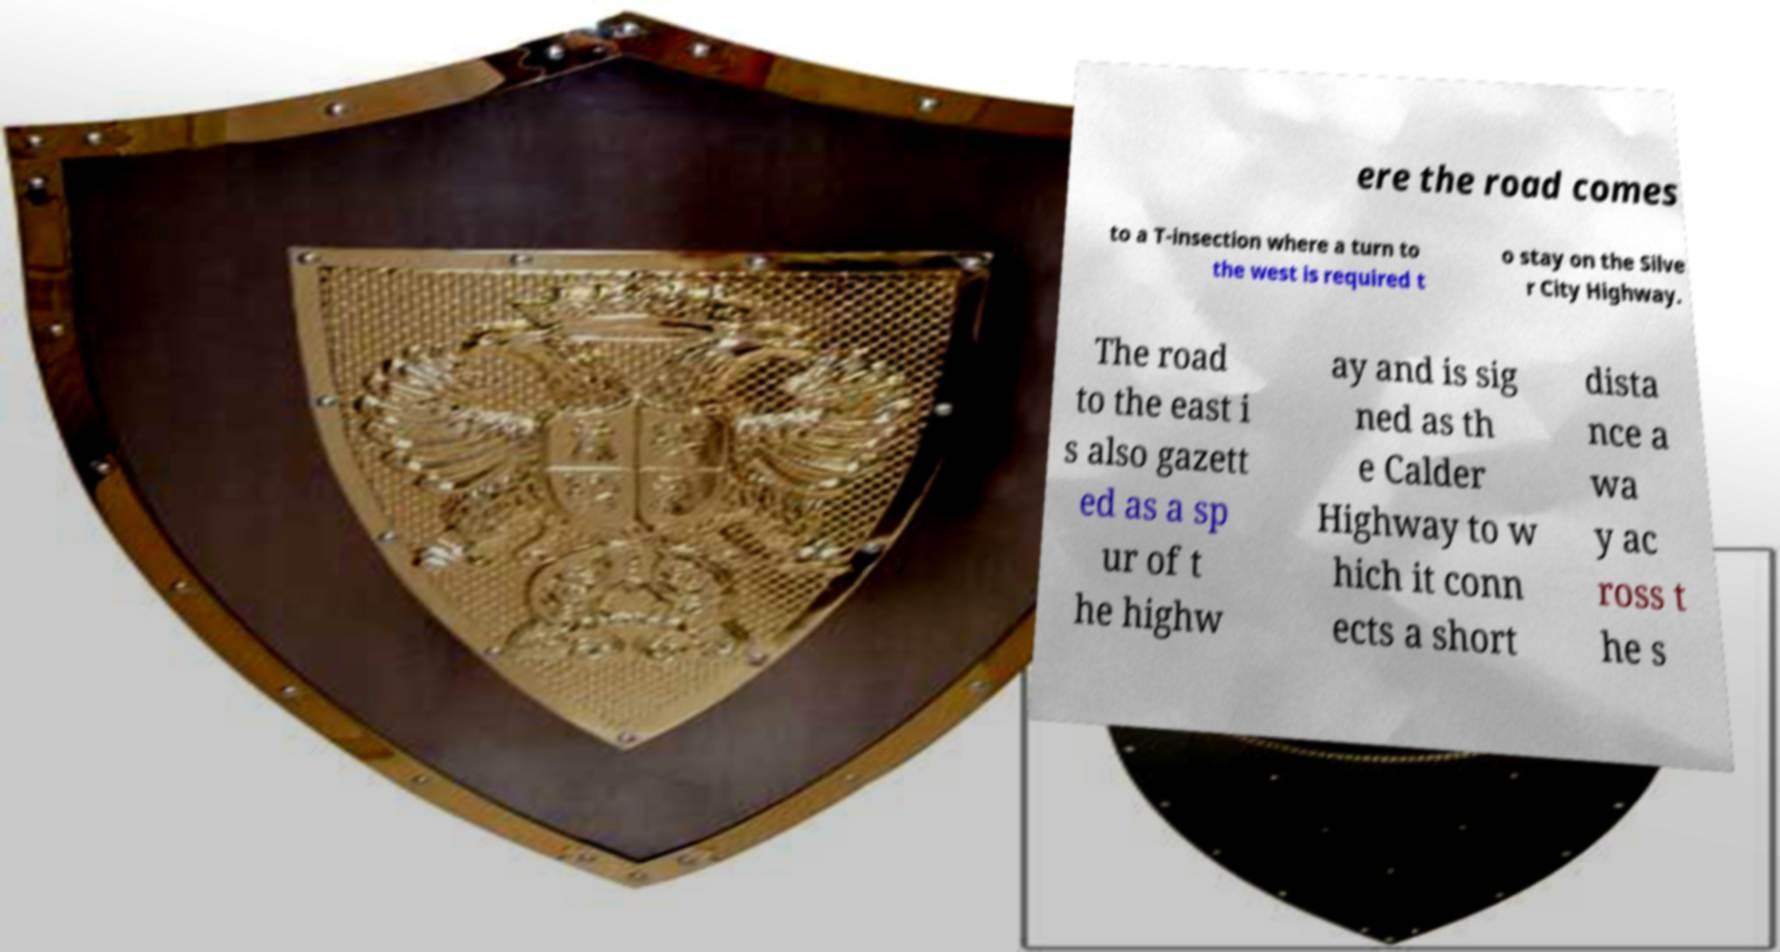For documentation purposes, I need the text within this image transcribed. Could you provide that? ere the road comes to a T-insection where a turn to the west is required t o stay on the Silve r City Highway. The road to the east i s also gazett ed as a sp ur of t he highw ay and is sig ned as th e Calder Highway to w hich it conn ects a short dista nce a wa y ac ross t he s 